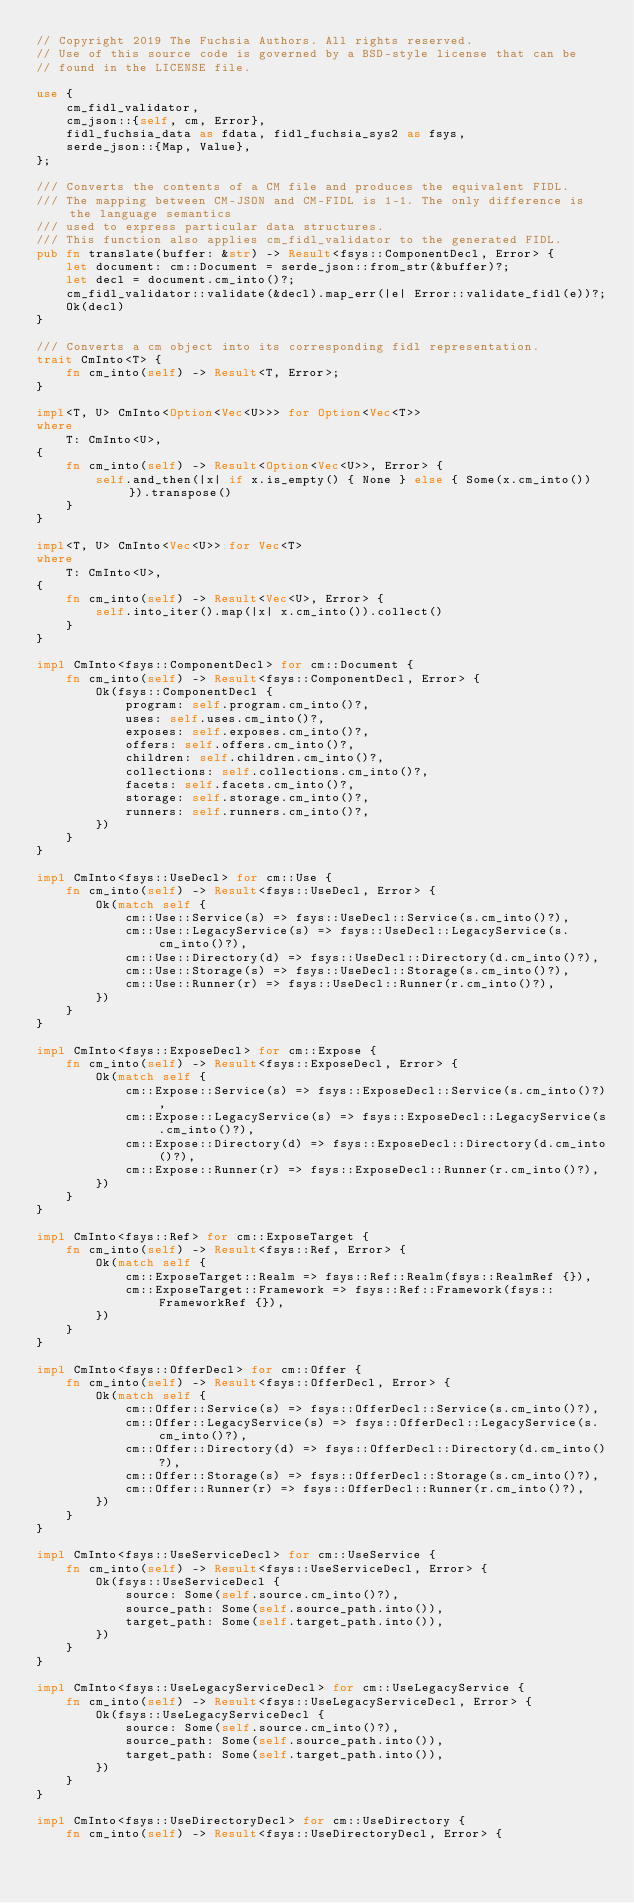<code> <loc_0><loc_0><loc_500><loc_500><_Rust_>// Copyright 2019 The Fuchsia Authors. All rights reserved.
// Use of this source code is governed by a BSD-style license that can be
// found in the LICENSE file.

use {
    cm_fidl_validator,
    cm_json::{self, cm, Error},
    fidl_fuchsia_data as fdata, fidl_fuchsia_sys2 as fsys,
    serde_json::{Map, Value},
};

/// Converts the contents of a CM file and produces the equivalent FIDL.
/// The mapping between CM-JSON and CM-FIDL is 1-1. The only difference is the language semantics
/// used to express particular data structures.
/// This function also applies cm_fidl_validator to the generated FIDL.
pub fn translate(buffer: &str) -> Result<fsys::ComponentDecl, Error> {
    let document: cm::Document = serde_json::from_str(&buffer)?;
    let decl = document.cm_into()?;
    cm_fidl_validator::validate(&decl).map_err(|e| Error::validate_fidl(e))?;
    Ok(decl)
}

/// Converts a cm object into its corresponding fidl representation.
trait CmInto<T> {
    fn cm_into(self) -> Result<T, Error>;
}

impl<T, U> CmInto<Option<Vec<U>>> for Option<Vec<T>>
where
    T: CmInto<U>,
{
    fn cm_into(self) -> Result<Option<Vec<U>>, Error> {
        self.and_then(|x| if x.is_empty() { None } else { Some(x.cm_into()) }).transpose()
    }
}

impl<T, U> CmInto<Vec<U>> for Vec<T>
where
    T: CmInto<U>,
{
    fn cm_into(self) -> Result<Vec<U>, Error> {
        self.into_iter().map(|x| x.cm_into()).collect()
    }
}

impl CmInto<fsys::ComponentDecl> for cm::Document {
    fn cm_into(self) -> Result<fsys::ComponentDecl, Error> {
        Ok(fsys::ComponentDecl {
            program: self.program.cm_into()?,
            uses: self.uses.cm_into()?,
            exposes: self.exposes.cm_into()?,
            offers: self.offers.cm_into()?,
            children: self.children.cm_into()?,
            collections: self.collections.cm_into()?,
            facets: self.facets.cm_into()?,
            storage: self.storage.cm_into()?,
            runners: self.runners.cm_into()?,
        })
    }
}

impl CmInto<fsys::UseDecl> for cm::Use {
    fn cm_into(self) -> Result<fsys::UseDecl, Error> {
        Ok(match self {
            cm::Use::Service(s) => fsys::UseDecl::Service(s.cm_into()?),
            cm::Use::LegacyService(s) => fsys::UseDecl::LegacyService(s.cm_into()?),
            cm::Use::Directory(d) => fsys::UseDecl::Directory(d.cm_into()?),
            cm::Use::Storage(s) => fsys::UseDecl::Storage(s.cm_into()?),
            cm::Use::Runner(r) => fsys::UseDecl::Runner(r.cm_into()?),
        })
    }
}

impl CmInto<fsys::ExposeDecl> for cm::Expose {
    fn cm_into(self) -> Result<fsys::ExposeDecl, Error> {
        Ok(match self {
            cm::Expose::Service(s) => fsys::ExposeDecl::Service(s.cm_into()?),
            cm::Expose::LegacyService(s) => fsys::ExposeDecl::LegacyService(s.cm_into()?),
            cm::Expose::Directory(d) => fsys::ExposeDecl::Directory(d.cm_into()?),
            cm::Expose::Runner(r) => fsys::ExposeDecl::Runner(r.cm_into()?),
        })
    }
}

impl CmInto<fsys::Ref> for cm::ExposeTarget {
    fn cm_into(self) -> Result<fsys::Ref, Error> {
        Ok(match self {
            cm::ExposeTarget::Realm => fsys::Ref::Realm(fsys::RealmRef {}),
            cm::ExposeTarget::Framework => fsys::Ref::Framework(fsys::FrameworkRef {}),
        })
    }
}

impl CmInto<fsys::OfferDecl> for cm::Offer {
    fn cm_into(self) -> Result<fsys::OfferDecl, Error> {
        Ok(match self {
            cm::Offer::Service(s) => fsys::OfferDecl::Service(s.cm_into()?),
            cm::Offer::LegacyService(s) => fsys::OfferDecl::LegacyService(s.cm_into()?),
            cm::Offer::Directory(d) => fsys::OfferDecl::Directory(d.cm_into()?),
            cm::Offer::Storage(s) => fsys::OfferDecl::Storage(s.cm_into()?),
            cm::Offer::Runner(r) => fsys::OfferDecl::Runner(r.cm_into()?),
        })
    }
}

impl CmInto<fsys::UseServiceDecl> for cm::UseService {
    fn cm_into(self) -> Result<fsys::UseServiceDecl, Error> {
        Ok(fsys::UseServiceDecl {
            source: Some(self.source.cm_into()?),
            source_path: Some(self.source_path.into()),
            target_path: Some(self.target_path.into()),
        })
    }
}

impl CmInto<fsys::UseLegacyServiceDecl> for cm::UseLegacyService {
    fn cm_into(self) -> Result<fsys::UseLegacyServiceDecl, Error> {
        Ok(fsys::UseLegacyServiceDecl {
            source: Some(self.source.cm_into()?),
            source_path: Some(self.source_path.into()),
            target_path: Some(self.target_path.into()),
        })
    }
}

impl CmInto<fsys::UseDirectoryDecl> for cm::UseDirectory {
    fn cm_into(self) -> Result<fsys::UseDirectoryDecl, Error> {</code> 